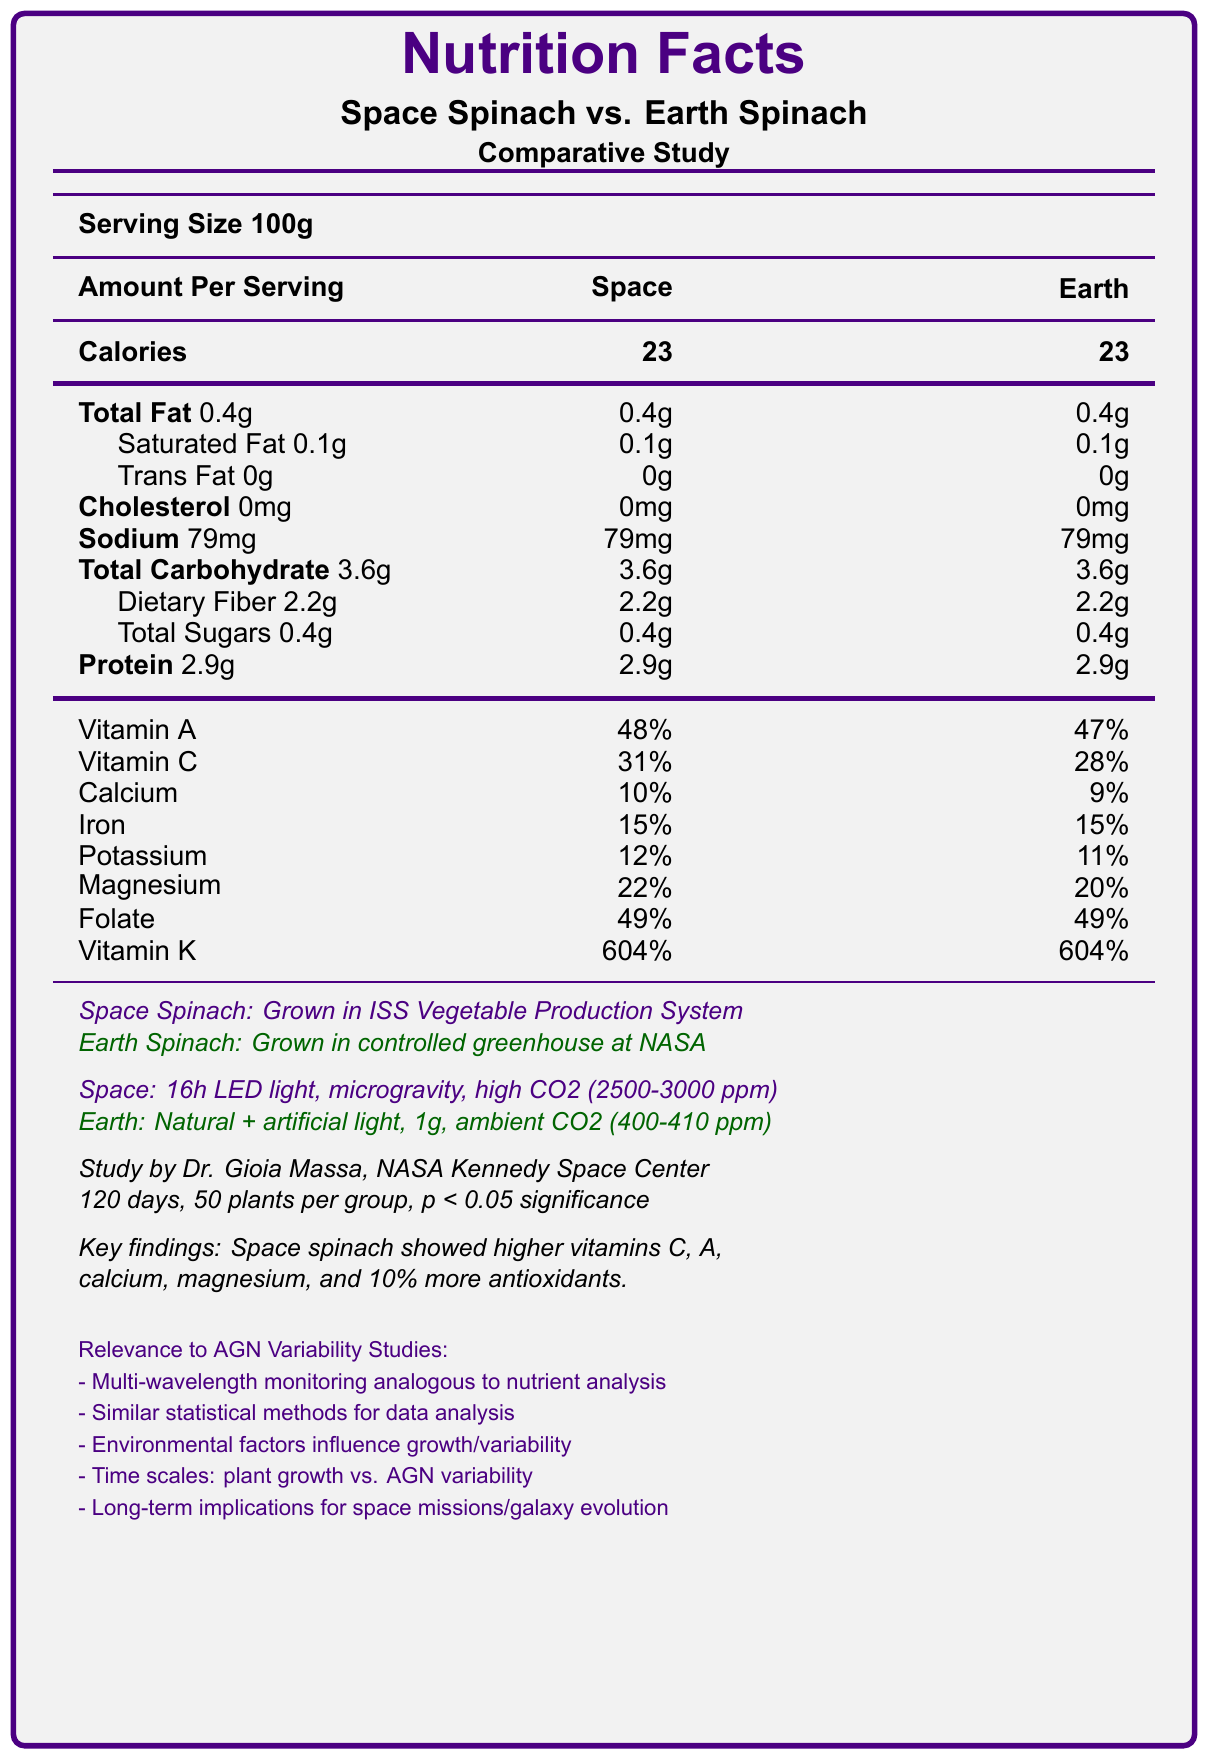who is the principal investigator of the study? The document mentions that the study was conducted by Dr. Gioia Massa from NASA Kennedy Space Center under the "study notes" section.
Answer: Dr. Gioia Massa what is the serving size for both space-grown and Earth-grown spinach? The serving size is clearly stated at the beginning of the document as "Serving Size 100g."
Answer: 100 grams what is the percentage of Vitamin C in space-grown spinach? In the vitamin section of the nutrition facts, space-grown spinach contains 31% of Vitamin C per serving.
Answer: 31% how does the calcium content differ between space-grown and Earth-grown spinach? The document lists calcium content percentages under the nutrition facts, indicating 10% for space-grown and 9% for Earth-grown spinach.
Answer: Space-grown spinach has 10% calcium, while Earth-grown spinach has 9%. what system is used to water the space-grown spinach? Information under "additional_info" mentions that the space-grown spinach uses a passive capillary-based watering system.
Answer: Passive capillary-based watering system which of the following vitamins is found in higher concentration in space-grown spinach compared to Earth-grown spinach? A. Vitamin A B. Vitamin B C. Vitamin C The document shows space-grown spinach has 31% of Vitamin C compared to 28% in Earth-grown spinach under the vitamin section.
Answer: C which condition was not part of the growth environment for space-grown spinach? 1. Microgravity 2. High CO2 levels 3. Earth's gravity Earth's gravity (1g) was specific to Earth-grown spinach, not part of the space-grown spinach conditions.
Answer: 3 Did the microgravity environment of space affect the physical characteristics of the spinach? The study notes key findings and mention that space-grown spinach had elongated stems and larger leaf surface area due to the microgravity environment.
Answer: Yes Summarize the key findings of this comparative study The key findings are summarized by looking at the concentrated differences in nutrient content, antioxidant capacity, and physical characteristics of space-grown spinach compared to Earth-grown spinach as given in the study notes.
Answer: Space-grown spinach showed higher nutrient concentrations for certain vitamins and minerals compared to Earth-grown spinach while maintaining similar macronutrient compositions. The space-grown spinach also had a higher antioxidant capacity, with differences attributed to the microgravity and controlled CO2 conditions. These findings have implications for future long-term space missions. how long was the experiment conducted for? The duration of the experiment is mentioned as 120 days in the study notes section.
Answer: 120 days what was the atmosphere's CO2 level for the Earth-grown spinach? The document under "additional_info" notes that the Earth's ambient CO2 levels were 400-410 ppm.
Answer: 400-410 ppm What did the statistical analysis of the study aim to test? As stated in the study notes, the study utilized a two-tailed t-test with p < 0.05 to determine significance.
Answer: Significance of differences with a two-tailed t-test, p < 0.05 considered significant who funded this comparative study? The document provides no information regarding the funding source of the study.
Answer: Cannot be determined what were the findings related to antioxidant capacity? This information is located in the key findings, indicating a 10% higher antioxidant capacity in space-grown spinach.
Answer: Space-grown spinach exhibited a 10% increase in antioxidant capacity compared to Earth-grown counterparts 